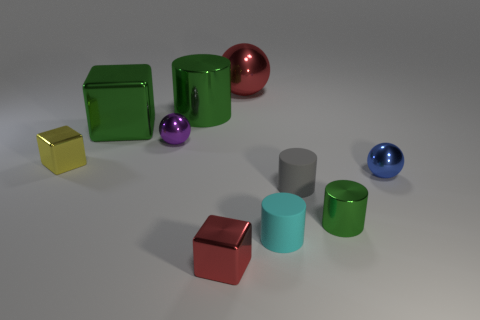Do the small metal cylinder and the large cube have the same color?
Offer a very short reply. Yes. Is the material of the small purple sphere the same as the tiny yellow cube?
Your response must be concise. Yes. There is a small metal cube behind the block that is in front of the yellow cube; what is its color?
Your answer should be compact. Yellow. There is a cylinder that is made of the same material as the gray object; what is its size?
Offer a terse response. Small. How many small green things are the same shape as the gray rubber object?
Your response must be concise. 1. How many things are red objects behind the red cube or cylinders behind the cyan object?
Your response must be concise. 4. How many small yellow blocks are in front of the small ball behind the blue metallic thing?
Give a very brief answer. 1. Do the green metallic object on the left side of the small purple shiny object and the blue object to the right of the gray cylinder have the same shape?
Your answer should be compact. No. There is a big object that is the same color as the large cylinder; what is its shape?
Keep it short and to the point. Cube. Are there any tiny gray objects made of the same material as the small green thing?
Offer a terse response. No. 